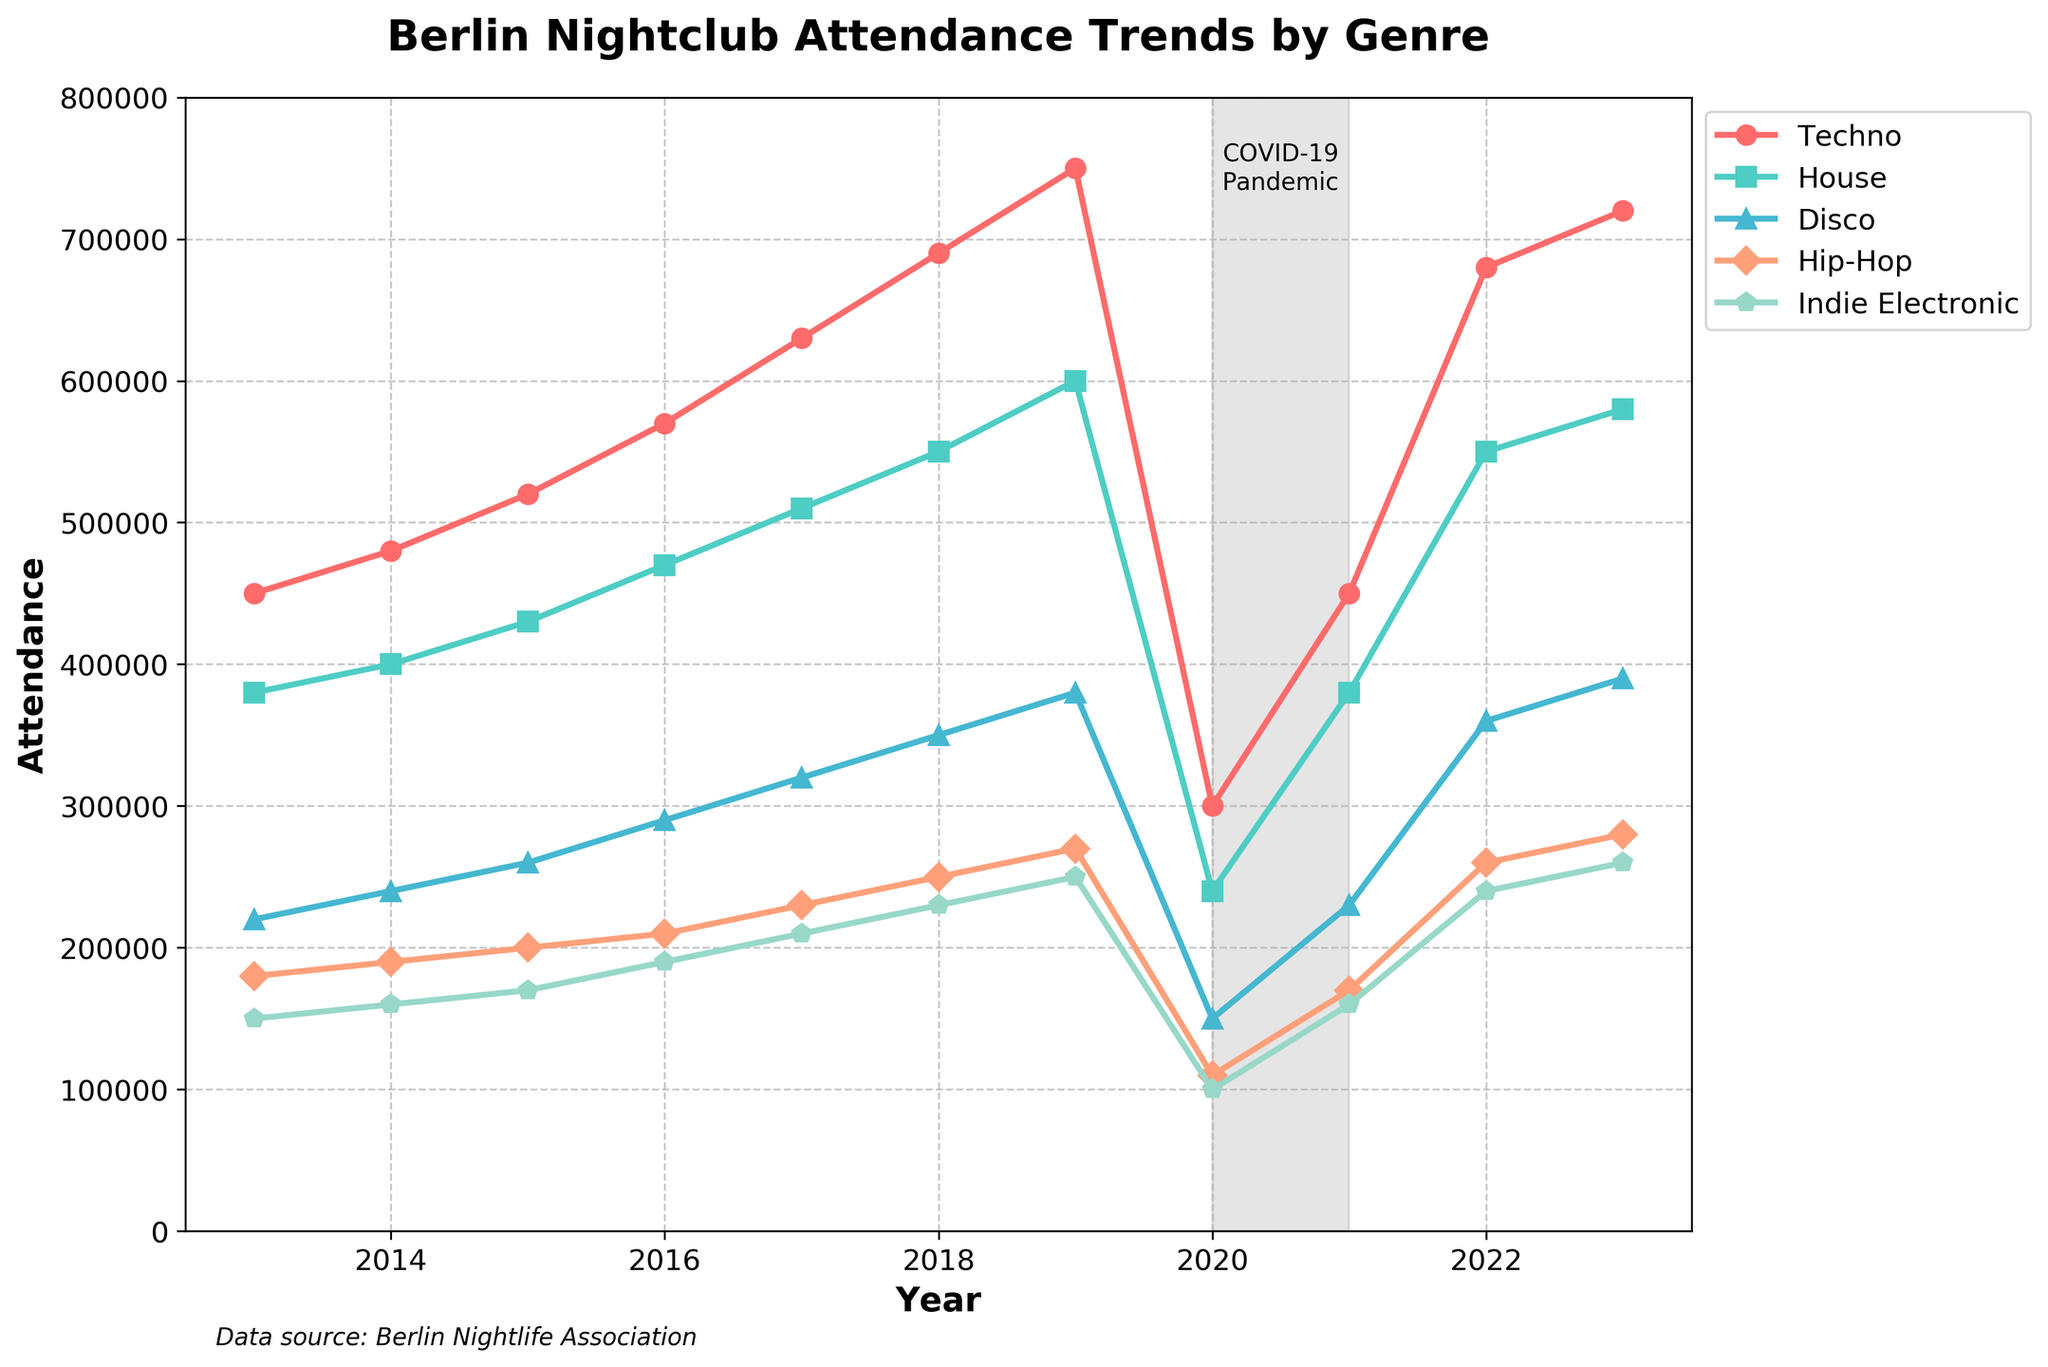what is the overall trend in Techno attendance over the decade? Techno attendance shows a general increase over the decade, except for a significant drop in 2020 due to the COVID-19 pandemic. From 2013 to 2023, it started at 450,000 and reached 720,000, indicating a growing popularity.
Answer: Increasing trend with a drop in 2020 How did House and Disco attendance compare in 2016? In 2016, House attendance was 470,000, while Disco attendance was 290,000. By comparing the two numbers, it's clear that House had a significantly higher attendance.
Answer: House attendance was higher than Disco Which year saw the maximum difference between Techno and Hip-Hop attendance? For each year, subtract the Hip-Hop attendance from the Techno attendance. The year with the highest difference is 2019, where Techno had 750,000 and Hip-Hop had 270,000, giving a difference of 480,000.
Answer: 2019 During which years did Indie Electronic attendance not show any increase? From the data, Indie Electronic attendance did not increase in the following intervals: 2014-2015, 2015-2016, 2018-2019, 2019-2020, 2021-2022. The attendance shows a stagnation or a drop in these periods.
Answer: 2014-2016, 2018-2020, 2021-2022 What portion of total attendance in 2022 was contributed by Disco? Sum the attendance of all genres in 2022: Techno (680,000) + House (550,000) + Disco (360,000) + Hip-Hop (260,000) + Indie Electronic (240,000) = 2,090,000. The portion contributed by Disco is 360,000 / 2,090,000 = 0.172 or 17.2%.
Answer: 17.2% Describe the attendance trend for Hip-Hop from 2019 to 2021. Hip-Hop attendance decreased from 270,000 in 2019 to 110,000 in 2020 due to COVID-19. It then partially recovered to 170,000 in 2021, showing a decrease followed by a partial recovery.
Answer: Decrease followed by a partial recovery Which genre had the smallest attendance drop during the COVID-19 pandemic (2020)? Calculate the drop for each genre from 2019 to 2020: 
Techno: 750,000 - 300,000 = 450,000 
House: 600,000 - 240,000 = 360,000 
Disco: 380,000 - 150,000 = 230,000 
Hip-Hop: 270,000 - 110,000 = 160,000 
Indie Electronic: 250,000 - 100,000 = 150,000 
Indie Electronic had the smallest drop of 150,000.
Answer: Indie Electronic What was the average attendance of House music from 2013 to 2023? Add up all the yearly attendance values for House from 2013 to 2023 and divide by the number of years: 
(380,000 + 400,000 + 430,000 + 470,000 + 510,000 + 550,000 + 600,000 + 240,000 + 380,000 + 550,000 + 580,000) / 11 = 4,740,000 / 11 ≈ 430,909.
Answer: Approximately 430,909 